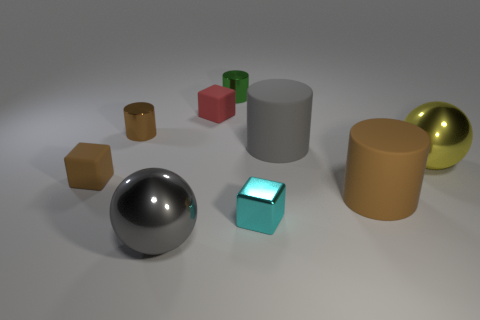The yellow ball has what size?
Make the answer very short. Large. There is a small object that is right of the tiny green metal object; what is its shape?
Make the answer very short. Cube. Does the metal sphere in front of the yellow ball have the same size as the tiny red rubber block?
Ensure brevity in your answer.  No. There is a large shiny object to the right of the big gray metal thing; is there a gray thing that is behind it?
Make the answer very short. Yes. Are there any yellow things made of the same material as the tiny cyan block?
Give a very brief answer. Yes. What material is the brown cylinder that is to the right of the tiny matte cube behind the brown shiny cylinder?
Ensure brevity in your answer.  Rubber. The small block that is on the right side of the brown metal cylinder and in front of the red object is made of what material?
Offer a very short reply. Metal. Are there an equal number of cyan metal blocks behind the cyan object and tiny green objects?
Offer a very short reply. No. What number of other tiny objects have the same shape as the red rubber object?
Offer a terse response. 2. There is a matte cylinder that is behind the metal sphere that is on the right side of the gray object that is in front of the large yellow shiny ball; what size is it?
Provide a short and direct response. Large. 